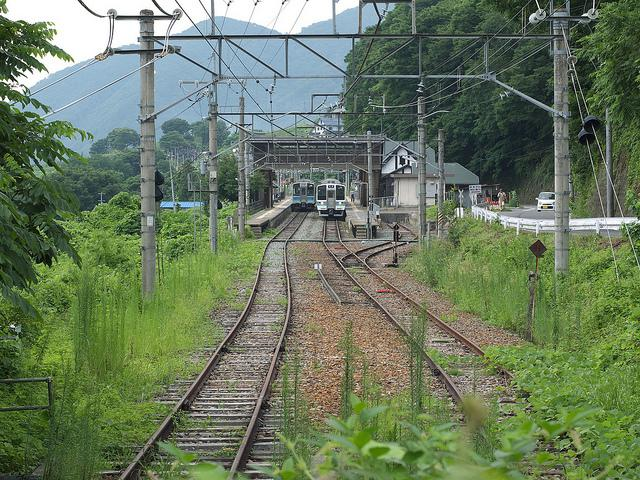There are two trains going down the rail of likely what country? japan 